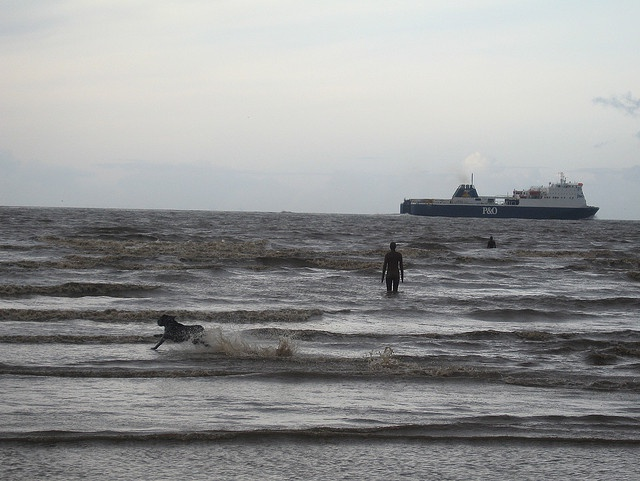Describe the objects in this image and their specific colors. I can see boat in lightgray, gray, black, and darkgray tones, dog in lightgray, black, gray, and darkgray tones, people in lightgray, black, gray, and darkgray tones, and people in lightgray, black, and gray tones in this image. 